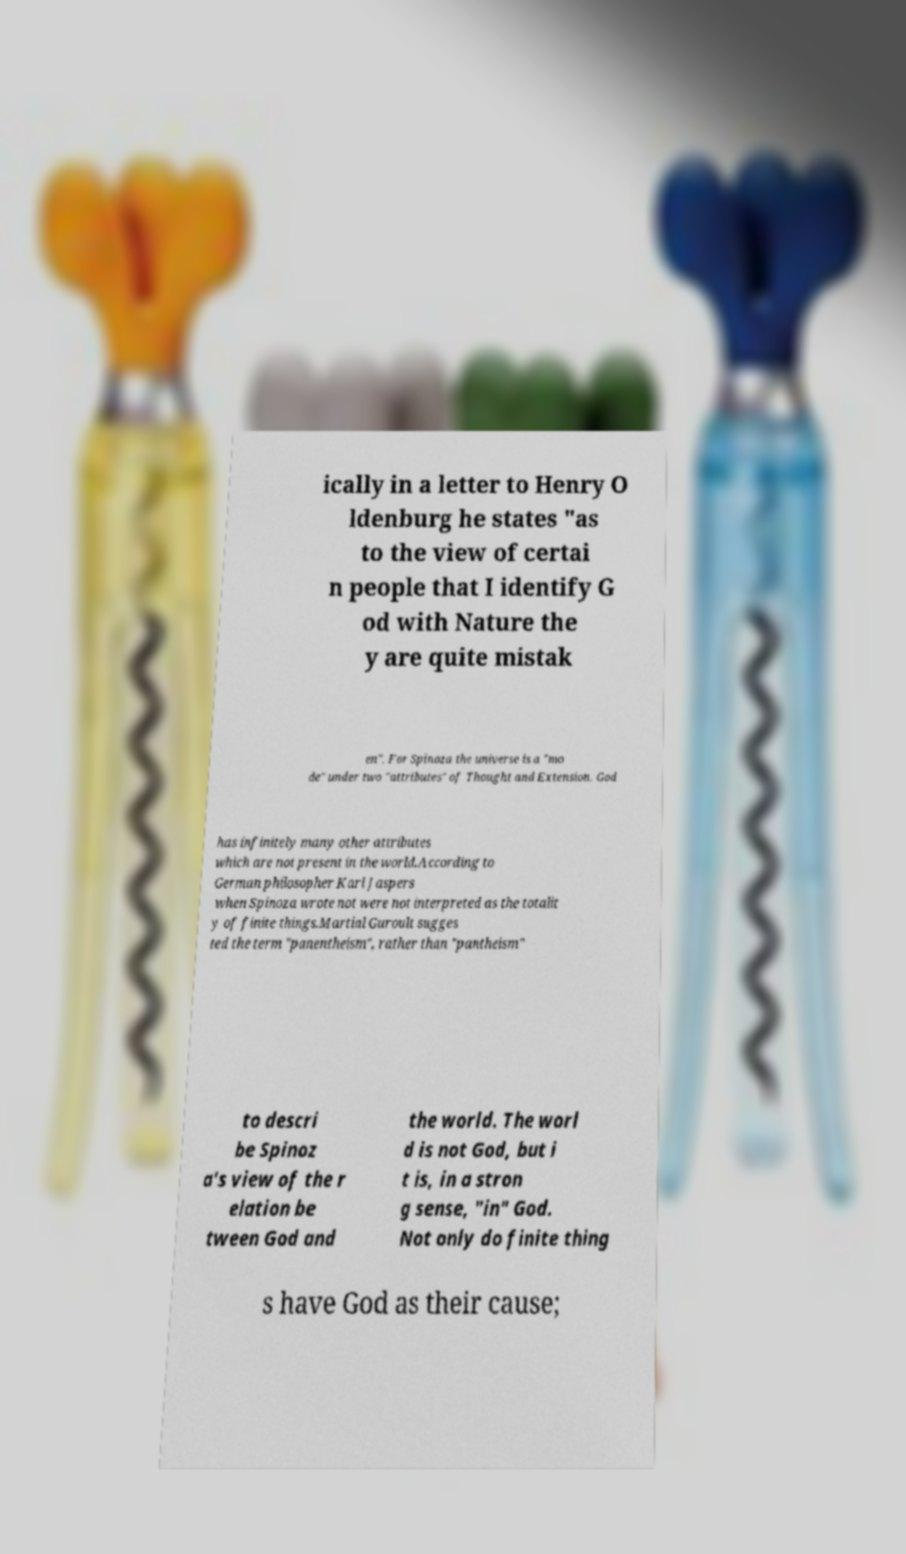Please read and relay the text visible in this image. What does it say? ically in a letter to Henry O ldenburg he states "as to the view of certai n people that I identify G od with Nature the y are quite mistak en". For Spinoza the universe is a "mo de" under two "attributes" of Thought and Extension. God has infinitely many other attributes which are not present in the world.According to German philosopher Karl Jaspers when Spinoza wrote not were not interpreted as the totalit y of finite things.Martial Guroult sugges ted the term "panentheism", rather than "pantheism" to descri be Spinoz a's view of the r elation be tween God and the world. The worl d is not God, but i t is, in a stron g sense, "in" God. Not only do finite thing s have God as their cause; 